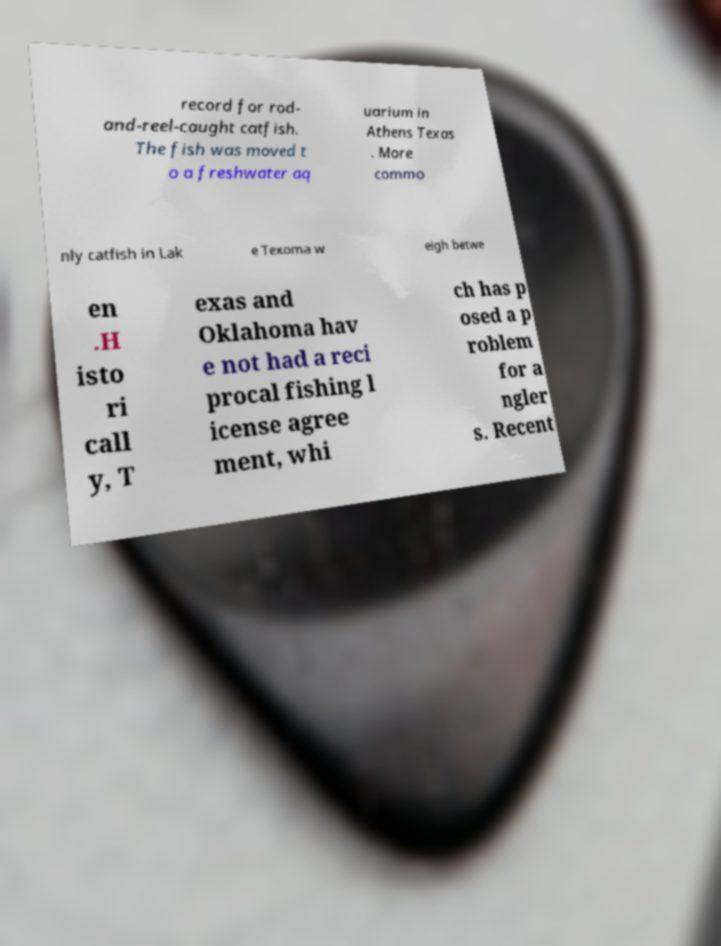Please read and relay the text visible in this image. What does it say? record for rod- and-reel-caught catfish. The fish was moved t o a freshwater aq uarium in Athens Texas . More commo nly catfish in Lak e Texoma w eigh betwe en .H isto ri call y, T exas and Oklahoma hav e not had a reci procal fishing l icense agree ment, whi ch has p osed a p roblem for a ngler s. Recent 